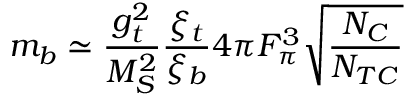Convert formula to latex. <formula><loc_0><loc_0><loc_500><loc_500>m _ { b } \simeq { \frac { g _ { t } ^ { 2 } } { M _ { S } ^ { 2 } } } { \frac { \xi _ { t } } { \xi _ { b } } } 4 \pi F _ { \pi } ^ { 3 } \sqrt { { \frac { N _ { C } } { N _ { T C } } } }</formula> 